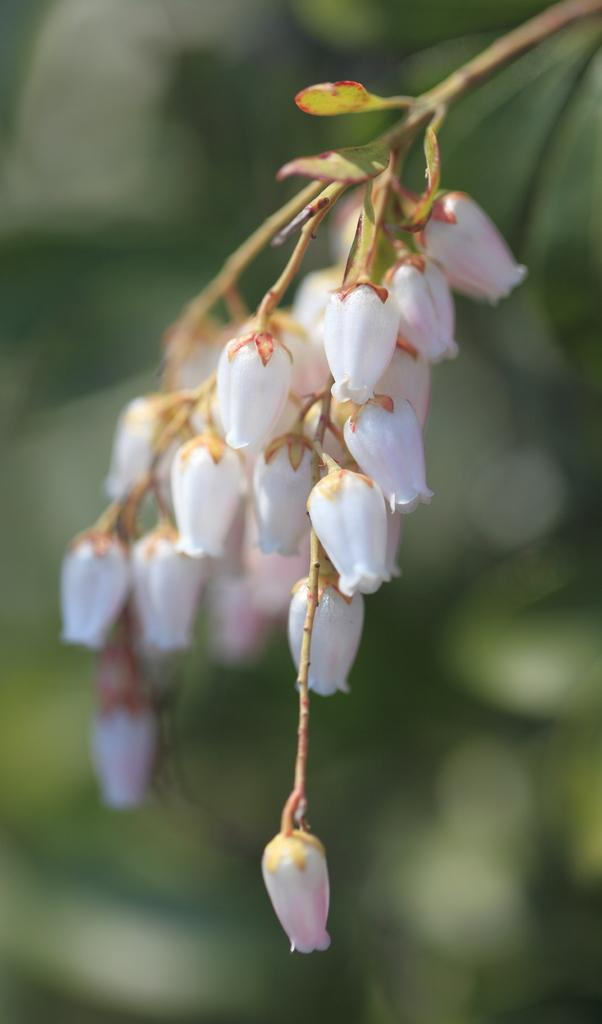What type of flowers are present in the image? There are white flowers in the image. Can you describe the background of the image? The background of the image is blurred. What type of bag is the man carrying in the image? There is no man or bag present in the image; it only features white flowers with a blurred background. 